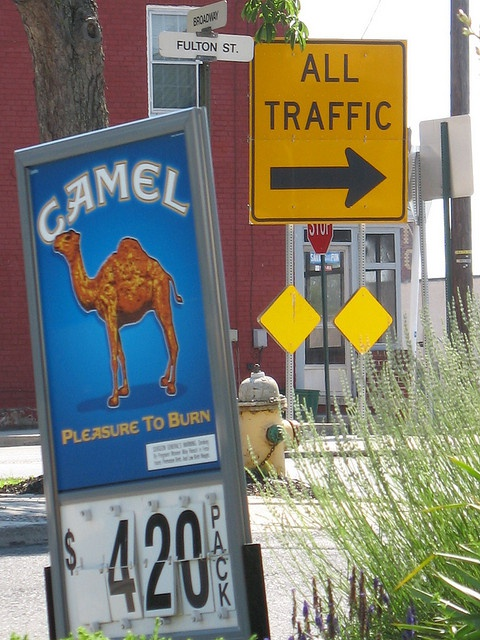Describe the objects in this image and their specific colors. I can see fire hydrant in brown, tan, darkgray, gray, and olive tones and stop sign in brown, maroon, and darkgray tones in this image. 